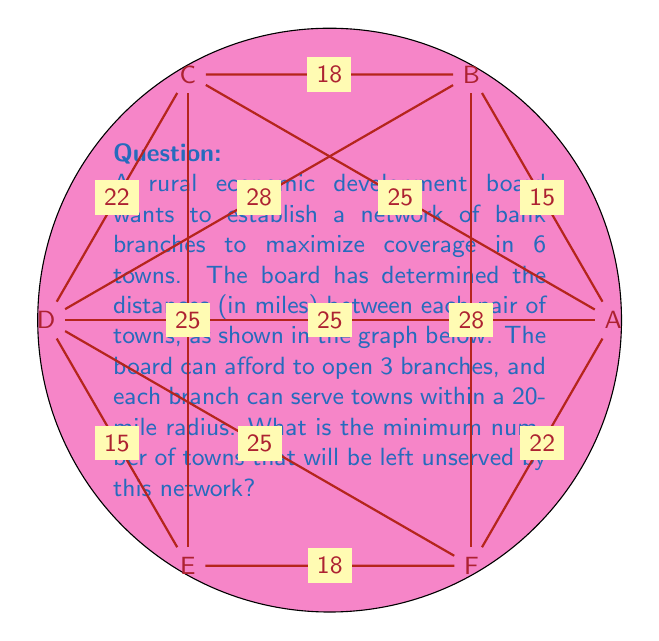Show me your answer to this math problem. To solve this problem, we need to find the optimal placement of 3 bank branches that will cover the maximum number of towns within a 20-mile radius. Let's approach this step-by-step:

1) First, we need to identify which towns can be covered by a single branch:
   - A branch in A can cover B and F
   - A branch in B can cover A and F
   - A branch in C can cover A and B
   - A branch in D can cover A and E
   - A branch in E can cover D and F
   - A branch in F can cover A and E

2) We want to maximize coverage, so we should look for combinations that cover the most towns:
   - Placing branches in A, C, and E would cover all towns except D
   - Placing branches in B, D, and F would cover all towns except C

3) These are the optimal solutions, as no other combination of 3 branches can cover more than 5 towns.

4) With either of these optimal placements, only 1 town will be left unserved.

Therefore, the minimum number of towns that will be left unserved is 1.
Answer: 1 